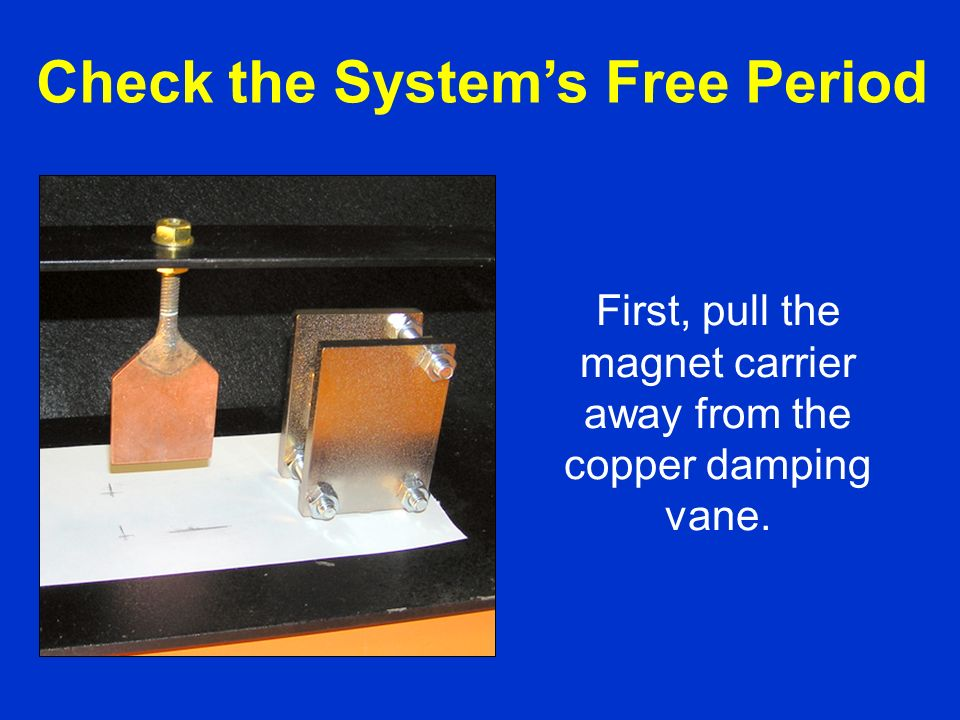What would happen if the vane was made of a different material, like plastic or wood? If the vane was made of a different material, such as plastic or wood, the demonstration of magnetic damping would not work the sharegpt4v/same way. Materials like plastic and wood are non-conductive, which means they do not allow the flow of eddy currents when exposed to a moving magnetic field. Without the induced eddy currents and the resulting magnetic field opposing the magnet's motion, there would be no damping effect. The magnet would continue to move freely without any noticeable reduction in its velocity, failing to demonstrate the principles of Lenz's Law and magnetic damping. 